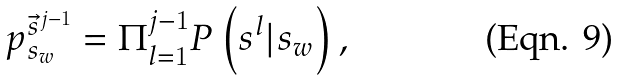<formula> <loc_0><loc_0><loc_500><loc_500>p ^ { \vec { s } ^ { j - 1 } } _ { s _ { w } } = \Pi _ { l = 1 } ^ { j - 1 } P \left ( s ^ { l } | s _ { w } \right ) ,</formula> 